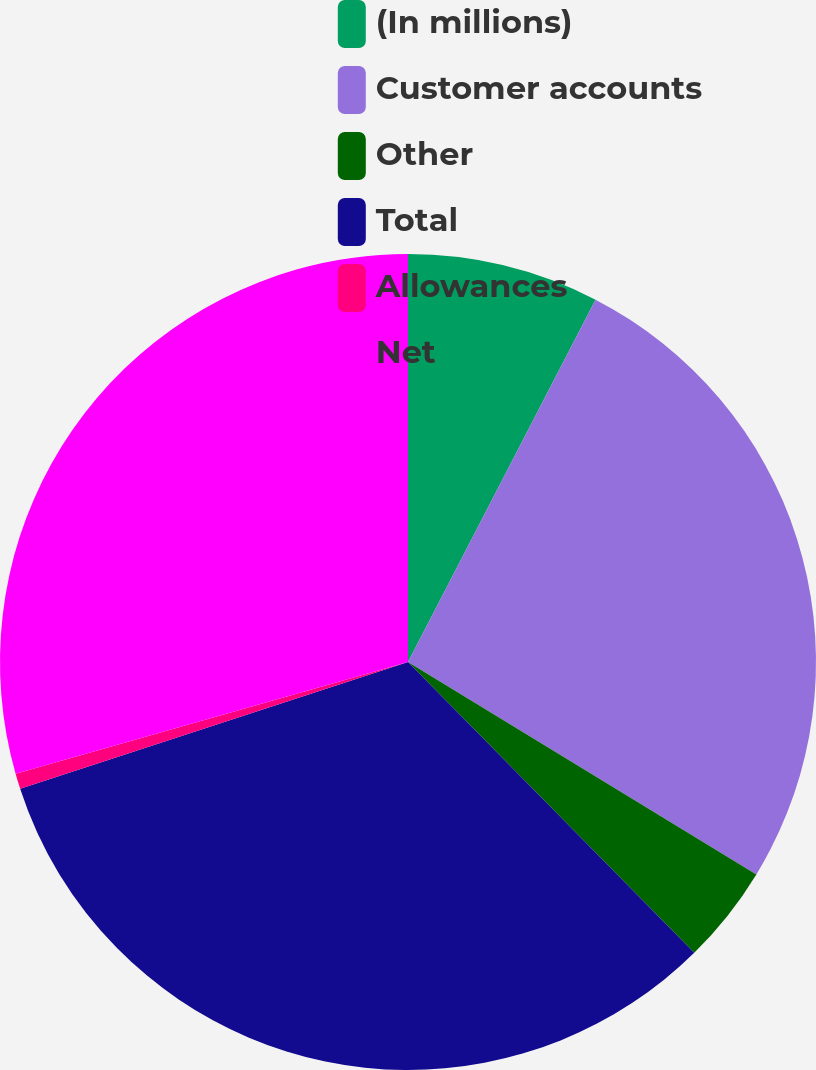Convert chart. <chart><loc_0><loc_0><loc_500><loc_500><pie_chart><fcel>(In millions)<fcel>Customer accounts<fcel>Other<fcel>Total<fcel>Allowances<fcel>Net<nl><fcel>7.6%<fcel>26.11%<fcel>3.91%<fcel>32.35%<fcel>0.61%<fcel>29.41%<nl></chart> 